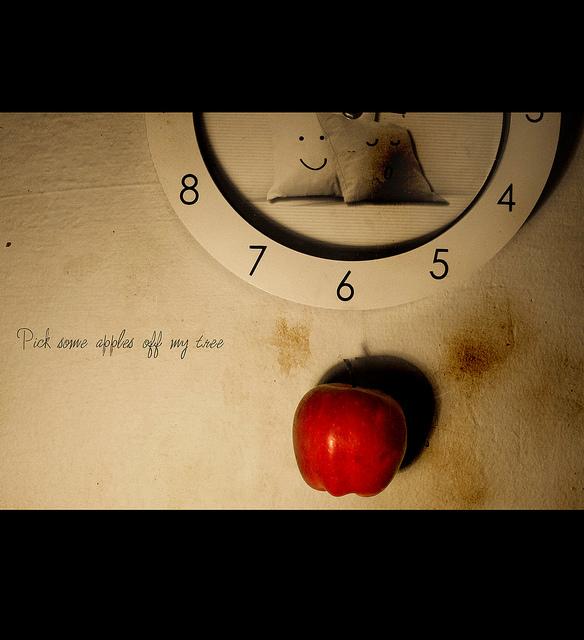What numbers are visible on the clock?
Answer briefly. 4-8. What kind of fruit is under the clock?
Short answer required. Apple. What does the writing say on the wall?
Quick response, please. Pick some apples off my tree. 